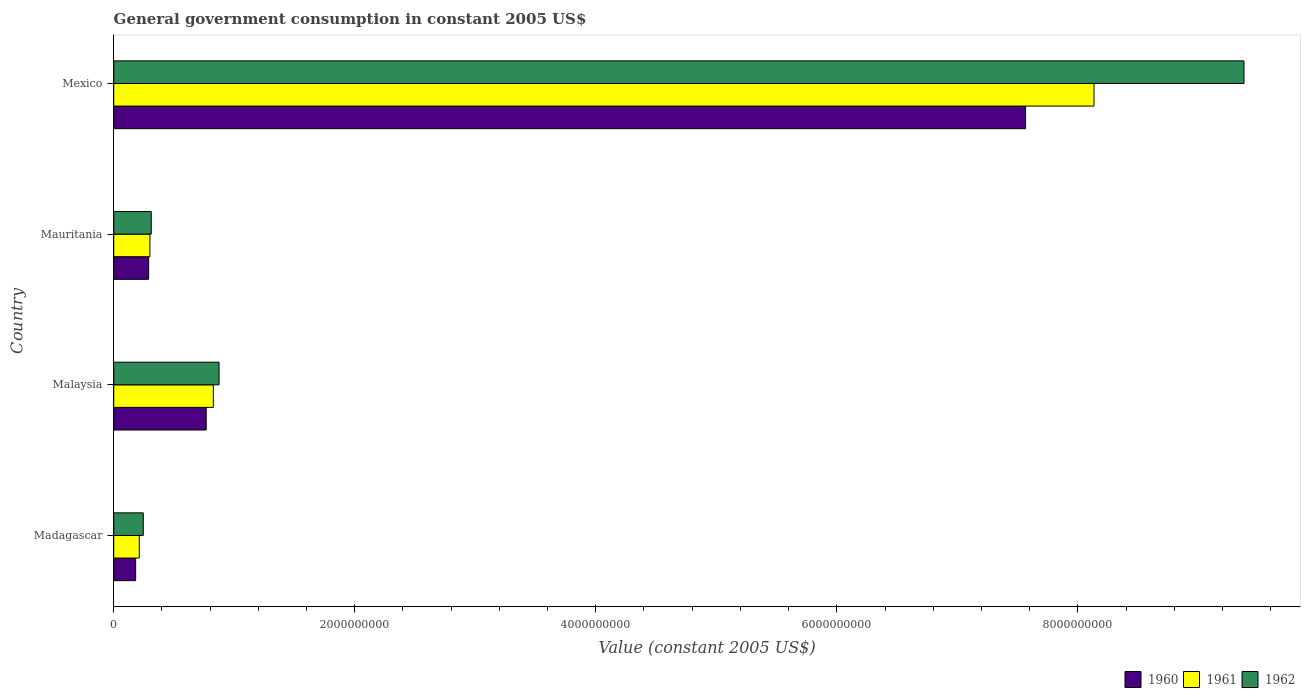How many groups of bars are there?
Your answer should be compact. 4. Are the number of bars per tick equal to the number of legend labels?
Your response must be concise. Yes. How many bars are there on the 4th tick from the top?
Keep it short and to the point. 3. What is the label of the 2nd group of bars from the top?
Provide a short and direct response. Mauritania. In how many cases, is the number of bars for a given country not equal to the number of legend labels?
Your answer should be compact. 0. What is the government conusmption in 1960 in Madagascar?
Give a very brief answer. 1.82e+08. Across all countries, what is the maximum government conusmption in 1962?
Your response must be concise. 9.38e+09. Across all countries, what is the minimum government conusmption in 1961?
Your answer should be very brief. 2.12e+08. In which country was the government conusmption in 1962 minimum?
Make the answer very short. Madagascar. What is the total government conusmption in 1961 in the graph?
Ensure brevity in your answer.  9.47e+09. What is the difference between the government conusmption in 1962 in Madagascar and that in Malaysia?
Your answer should be very brief. -6.29e+08. What is the difference between the government conusmption in 1960 in Madagascar and the government conusmption in 1962 in Mexico?
Provide a short and direct response. -9.20e+09. What is the average government conusmption in 1962 per country?
Give a very brief answer. 2.70e+09. What is the difference between the government conusmption in 1962 and government conusmption in 1961 in Mauritania?
Keep it short and to the point. 1.09e+07. In how many countries, is the government conusmption in 1961 greater than 9200000000 US$?
Offer a very short reply. 0. What is the ratio of the government conusmption in 1960 in Madagascar to that in Malaysia?
Ensure brevity in your answer.  0.24. What is the difference between the highest and the second highest government conusmption in 1962?
Make the answer very short. 8.50e+09. What is the difference between the highest and the lowest government conusmption in 1962?
Offer a terse response. 9.13e+09. What does the 3rd bar from the top in Mauritania represents?
Your answer should be very brief. 1960. Is it the case that in every country, the sum of the government conusmption in 1960 and government conusmption in 1962 is greater than the government conusmption in 1961?
Offer a very short reply. Yes. How many bars are there?
Provide a short and direct response. 12. Are all the bars in the graph horizontal?
Your response must be concise. Yes. How many countries are there in the graph?
Provide a short and direct response. 4. What is the difference between two consecutive major ticks on the X-axis?
Offer a very short reply. 2.00e+09. Does the graph contain any zero values?
Make the answer very short. No. How are the legend labels stacked?
Provide a succinct answer. Horizontal. What is the title of the graph?
Your answer should be very brief. General government consumption in constant 2005 US$. Does "1998" appear as one of the legend labels in the graph?
Provide a succinct answer. No. What is the label or title of the X-axis?
Give a very brief answer. Value (constant 2005 US$). What is the label or title of the Y-axis?
Provide a short and direct response. Country. What is the Value (constant 2005 US$) of 1960 in Madagascar?
Give a very brief answer. 1.82e+08. What is the Value (constant 2005 US$) in 1961 in Madagascar?
Give a very brief answer. 2.12e+08. What is the Value (constant 2005 US$) in 1962 in Madagascar?
Ensure brevity in your answer.  2.45e+08. What is the Value (constant 2005 US$) of 1960 in Malaysia?
Provide a succinct answer. 7.67e+08. What is the Value (constant 2005 US$) in 1961 in Malaysia?
Ensure brevity in your answer.  8.26e+08. What is the Value (constant 2005 US$) in 1962 in Malaysia?
Ensure brevity in your answer.  8.74e+08. What is the Value (constant 2005 US$) in 1960 in Mauritania?
Offer a very short reply. 2.89e+08. What is the Value (constant 2005 US$) in 1961 in Mauritania?
Provide a succinct answer. 3.00e+08. What is the Value (constant 2005 US$) in 1962 in Mauritania?
Make the answer very short. 3.11e+08. What is the Value (constant 2005 US$) in 1960 in Mexico?
Offer a very short reply. 7.57e+09. What is the Value (constant 2005 US$) in 1961 in Mexico?
Ensure brevity in your answer.  8.13e+09. What is the Value (constant 2005 US$) in 1962 in Mexico?
Your answer should be compact. 9.38e+09. Across all countries, what is the maximum Value (constant 2005 US$) in 1960?
Keep it short and to the point. 7.57e+09. Across all countries, what is the maximum Value (constant 2005 US$) of 1961?
Make the answer very short. 8.13e+09. Across all countries, what is the maximum Value (constant 2005 US$) of 1962?
Give a very brief answer. 9.38e+09. Across all countries, what is the minimum Value (constant 2005 US$) of 1960?
Ensure brevity in your answer.  1.82e+08. Across all countries, what is the minimum Value (constant 2005 US$) in 1961?
Offer a very short reply. 2.12e+08. Across all countries, what is the minimum Value (constant 2005 US$) of 1962?
Ensure brevity in your answer.  2.45e+08. What is the total Value (constant 2005 US$) of 1960 in the graph?
Keep it short and to the point. 8.81e+09. What is the total Value (constant 2005 US$) of 1961 in the graph?
Give a very brief answer. 9.47e+09. What is the total Value (constant 2005 US$) in 1962 in the graph?
Ensure brevity in your answer.  1.08e+1. What is the difference between the Value (constant 2005 US$) in 1960 in Madagascar and that in Malaysia?
Give a very brief answer. -5.85e+08. What is the difference between the Value (constant 2005 US$) of 1961 in Madagascar and that in Malaysia?
Give a very brief answer. -6.14e+08. What is the difference between the Value (constant 2005 US$) of 1962 in Madagascar and that in Malaysia?
Your answer should be compact. -6.29e+08. What is the difference between the Value (constant 2005 US$) in 1960 in Madagascar and that in Mauritania?
Give a very brief answer. -1.08e+08. What is the difference between the Value (constant 2005 US$) of 1961 in Madagascar and that in Mauritania?
Make the answer very short. -8.84e+07. What is the difference between the Value (constant 2005 US$) in 1962 in Madagascar and that in Mauritania?
Make the answer very short. -6.62e+07. What is the difference between the Value (constant 2005 US$) in 1960 in Madagascar and that in Mexico?
Offer a terse response. -7.38e+09. What is the difference between the Value (constant 2005 US$) of 1961 in Madagascar and that in Mexico?
Ensure brevity in your answer.  -7.92e+09. What is the difference between the Value (constant 2005 US$) in 1962 in Madagascar and that in Mexico?
Offer a very short reply. -9.13e+09. What is the difference between the Value (constant 2005 US$) of 1960 in Malaysia and that in Mauritania?
Keep it short and to the point. 4.78e+08. What is the difference between the Value (constant 2005 US$) of 1961 in Malaysia and that in Mauritania?
Provide a short and direct response. 5.26e+08. What is the difference between the Value (constant 2005 US$) in 1962 in Malaysia and that in Mauritania?
Offer a terse response. 5.63e+08. What is the difference between the Value (constant 2005 US$) of 1960 in Malaysia and that in Mexico?
Your answer should be compact. -6.80e+09. What is the difference between the Value (constant 2005 US$) in 1961 in Malaysia and that in Mexico?
Offer a terse response. -7.31e+09. What is the difference between the Value (constant 2005 US$) of 1962 in Malaysia and that in Mexico?
Offer a terse response. -8.50e+09. What is the difference between the Value (constant 2005 US$) in 1960 in Mauritania and that in Mexico?
Your response must be concise. -7.28e+09. What is the difference between the Value (constant 2005 US$) in 1961 in Mauritania and that in Mexico?
Ensure brevity in your answer.  -7.83e+09. What is the difference between the Value (constant 2005 US$) of 1962 in Mauritania and that in Mexico?
Your answer should be compact. -9.07e+09. What is the difference between the Value (constant 2005 US$) in 1960 in Madagascar and the Value (constant 2005 US$) in 1961 in Malaysia?
Your answer should be compact. -6.45e+08. What is the difference between the Value (constant 2005 US$) in 1960 in Madagascar and the Value (constant 2005 US$) in 1962 in Malaysia?
Make the answer very short. -6.92e+08. What is the difference between the Value (constant 2005 US$) of 1961 in Madagascar and the Value (constant 2005 US$) of 1962 in Malaysia?
Ensure brevity in your answer.  -6.62e+08. What is the difference between the Value (constant 2005 US$) of 1960 in Madagascar and the Value (constant 2005 US$) of 1961 in Mauritania?
Make the answer very short. -1.19e+08. What is the difference between the Value (constant 2005 US$) in 1960 in Madagascar and the Value (constant 2005 US$) in 1962 in Mauritania?
Make the answer very short. -1.30e+08. What is the difference between the Value (constant 2005 US$) in 1961 in Madagascar and the Value (constant 2005 US$) in 1962 in Mauritania?
Offer a very short reply. -9.93e+07. What is the difference between the Value (constant 2005 US$) of 1960 in Madagascar and the Value (constant 2005 US$) of 1961 in Mexico?
Make the answer very short. -7.95e+09. What is the difference between the Value (constant 2005 US$) of 1960 in Madagascar and the Value (constant 2005 US$) of 1962 in Mexico?
Keep it short and to the point. -9.20e+09. What is the difference between the Value (constant 2005 US$) in 1961 in Madagascar and the Value (constant 2005 US$) in 1962 in Mexico?
Ensure brevity in your answer.  -9.17e+09. What is the difference between the Value (constant 2005 US$) of 1960 in Malaysia and the Value (constant 2005 US$) of 1961 in Mauritania?
Offer a very short reply. 4.67e+08. What is the difference between the Value (constant 2005 US$) in 1960 in Malaysia and the Value (constant 2005 US$) in 1962 in Mauritania?
Provide a succinct answer. 4.56e+08. What is the difference between the Value (constant 2005 US$) in 1961 in Malaysia and the Value (constant 2005 US$) in 1962 in Mauritania?
Offer a very short reply. 5.15e+08. What is the difference between the Value (constant 2005 US$) in 1960 in Malaysia and the Value (constant 2005 US$) in 1961 in Mexico?
Your answer should be very brief. -7.37e+09. What is the difference between the Value (constant 2005 US$) in 1960 in Malaysia and the Value (constant 2005 US$) in 1962 in Mexico?
Provide a succinct answer. -8.61e+09. What is the difference between the Value (constant 2005 US$) in 1961 in Malaysia and the Value (constant 2005 US$) in 1962 in Mexico?
Provide a short and direct response. -8.55e+09. What is the difference between the Value (constant 2005 US$) in 1960 in Mauritania and the Value (constant 2005 US$) in 1961 in Mexico?
Your answer should be very brief. -7.85e+09. What is the difference between the Value (constant 2005 US$) in 1960 in Mauritania and the Value (constant 2005 US$) in 1962 in Mexico?
Keep it short and to the point. -9.09e+09. What is the difference between the Value (constant 2005 US$) in 1961 in Mauritania and the Value (constant 2005 US$) in 1962 in Mexico?
Offer a very short reply. -9.08e+09. What is the average Value (constant 2005 US$) in 1960 per country?
Provide a short and direct response. 2.20e+09. What is the average Value (constant 2005 US$) of 1961 per country?
Offer a very short reply. 2.37e+09. What is the average Value (constant 2005 US$) of 1962 per country?
Provide a short and direct response. 2.70e+09. What is the difference between the Value (constant 2005 US$) in 1960 and Value (constant 2005 US$) in 1961 in Madagascar?
Your answer should be compact. -3.02e+07. What is the difference between the Value (constant 2005 US$) of 1960 and Value (constant 2005 US$) of 1962 in Madagascar?
Your response must be concise. -6.34e+07. What is the difference between the Value (constant 2005 US$) of 1961 and Value (constant 2005 US$) of 1962 in Madagascar?
Make the answer very short. -3.32e+07. What is the difference between the Value (constant 2005 US$) of 1960 and Value (constant 2005 US$) of 1961 in Malaysia?
Keep it short and to the point. -5.92e+07. What is the difference between the Value (constant 2005 US$) of 1960 and Value (constant 2005 US$) of 1962 in Malaysia?
Your response must be concise. -1.07e+08. What is the difference between the Value (constant 2005 US$) in 1961 and Value (constant 2005 US$) in 1962 in Malaysia?
Provide a short and direct response. -4.75e+07. What is the difference between the Value (constant 2005 US$) in 1960 and Value (constant 2005 US$) in 1961 in Mauritania?
Ensure brevity in your answer.  -1.09e+07. What is the difference between the Value (constant 2005 US$) of 1960 and Value (constant 2005 US$) of 1962 in Mauritania?
Make the answer very short. -2.18e+07. What is the difference between the Value (constant 2005 US$) in 1961 and Value (constant 2005 US$) in 1962 in Mauritania?
Your response must be concise. -1.09e+07. What is the difference between the Value (constant 2005 US$) of 1960 and Value (constant 2005 US$) of 1961 in Mexico?
Make the answer very short. -5.68e+08. What is the difference between the Value (constant 2005 US$) in 1960 and Value (constant 2005 US$) in 1962 in Mexico?
Keep it short and to the point. -1.81e+09. What is the difference between the Value (constant 2005 US$) of 1961 and Value (constant 2005 US$) of 1962 in Mexico?
Ensure brevity in your answer.  -1.24e+09. What is the ratio of the Value (constant 2005 US$) of 1960 in Madagascar to that in Malaysia?
Your answer should be very brief. 0.24. What is the ratio of the Value (constant 2005 US$) of 1961 in Madagascar to that in Malaysia?
Provide a succinct answer. 0.26. What is the ratio of the Value (constant 2005 US$) of 1962 in Madagascar to that in Malaysia?
Provide a succinct answer. 0.28. What is the ratio of the Value (constant 2005 US$) in 1960 in Madagascar to that in Mauritania?
Offer a terse response. 0.63. What is the ratio of the Value (constant 2005 US$) of 1961 in Madagascar to that in Mauritania?
Keep it short and to the point. 0.71. What is the ratio of the Value (constant 2005 US$) of 1962 in Madagascar to that in Mauritania?
Give a very brief answer. 0.79. What is the ratio of the Value (constant 2005 US$) in 1960 in Madagascar to that in Mexico?
Provide a succinct answer. 0.02. What is the ratio of the Value (constant 2005 US$) of 1961 in Madagascar to that in Mexico?
Your answer should be compact. 0.03. What is the ratio of the Value (constant 2005 US$) of 1962 in Madagascar to that in Mexico?
Provide a succinct answer. 0.03. What is the ratio of the Value (constant 2005 US$) of 1960 in Malaysia to that in Mauritania?
Provide a short and direct response. 2.65. What is the ratio of the Value (constant 2005 US$) of 1961 in Malaysia to that in Mauritania?
Give a very brief answer. 2.75. What is the ratio of the Value (constant 2005 US$) in 1962 in Malaysia to that in Mauritania?
Provide a succinct answer. 2.81. What is the ratio of the Value (constant 2005 US$) of 1960 in Malaysia to that in Mexico?
Your answer should be very brief. 0.1. What is the ratio of the Value (constant 2005 US$) in 1961 in Malaysia to that in Mexico?
Your response must be concise. 0.1. What is the ratio of the Value (constant 2005 US$) of 1962 in Malaysia to that in Mexico?
Your answer should be compact. 0.09. What is the ratio of the Value (constant 2005 US$) in 1960 in Mauritania to that in Mexico?
Ensure brevity in your answer.  0.04. What is the ratio of the Value (constant 2005 US$) in 1961 in Mauritania to that in Mexico?
Ensure brevity in your answer.  0.04. What is the ratio of the Value (constant 2005 US$) of 1962 in Mauritania to that in Mexico?
Provide a succinct answer. 0.03. What is the difference between the highest and the second highest Value (constant 2005 US$) of 1960?
Provide a succinct answer. 6.80e+09. What is the difference between the highest and the second highest Value (constant 2005 US$) in 1961?
Provide a succinct answer. 7.31e+09. What is the difference between the highest and the second highest Value (constant 2005 US$) in 1962?
Ensure brevity in your answer.  8.50e+09. What is the difference between the highest and the lowest Value (constant 2005 US$) in 1960?
Keep it short and to the point. 7.38e+09. What is the difference between the highest and the lowest Value (constant 2005 US$) in 1961?
Offer a terse response. 7.92e+09. What is the difference between the highest and the lowest Value (constant 2005 US$) in 1962?
Keep it short and to the point. 9.13e+09. 